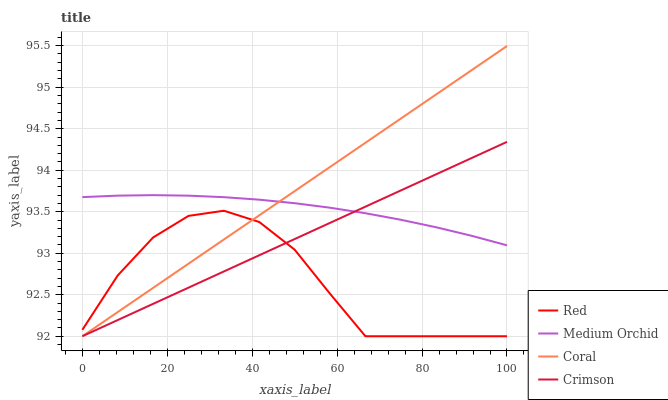Does Red have the minimum area under the curve?
Answer yes or no. Yes. Does Coral have the maximum area under the curve?
Answer yes or no. Yes. Does Medium Orchid have the minimum area under the curve?
Answer yes or no. No. Does Medium Orchid have the maximum area under the curve?
Answer yes or no. No. Is Coral the smoothest?
Answer yes or no. Yes. Is Red the roughest?
Answer yes or no. Yes. Is Medium Orchid the smoothest?
Answer yes or no. No. Is Medium Orchid the roughest?
Answer yes or no. No. Does Crimson have the lowest value?
Answer yes or no. Yes. Does Medium Orchid have the lowest value?
Answer yes or no. No. Does Coral have the highest value?
Answer yes or no. Yes. Does Medium Orchid have the highest value?
Answer yes or no. No. Is Red less than Medium Orchid?
Answer yes or no. Yes. Is Medium Orchid greater than Red?
Answer yes or no. Yes. Does Medium Orchid intersect Crimson?
Answer yes or no. Yes. Is Medium Orchid less than Crimson?
Answer yes or no. No. Is Medium Orchid greater than Crimson?
Answer yes or no. No. Does Red intersect Medium Orchid?
Answer yes or no. No. 